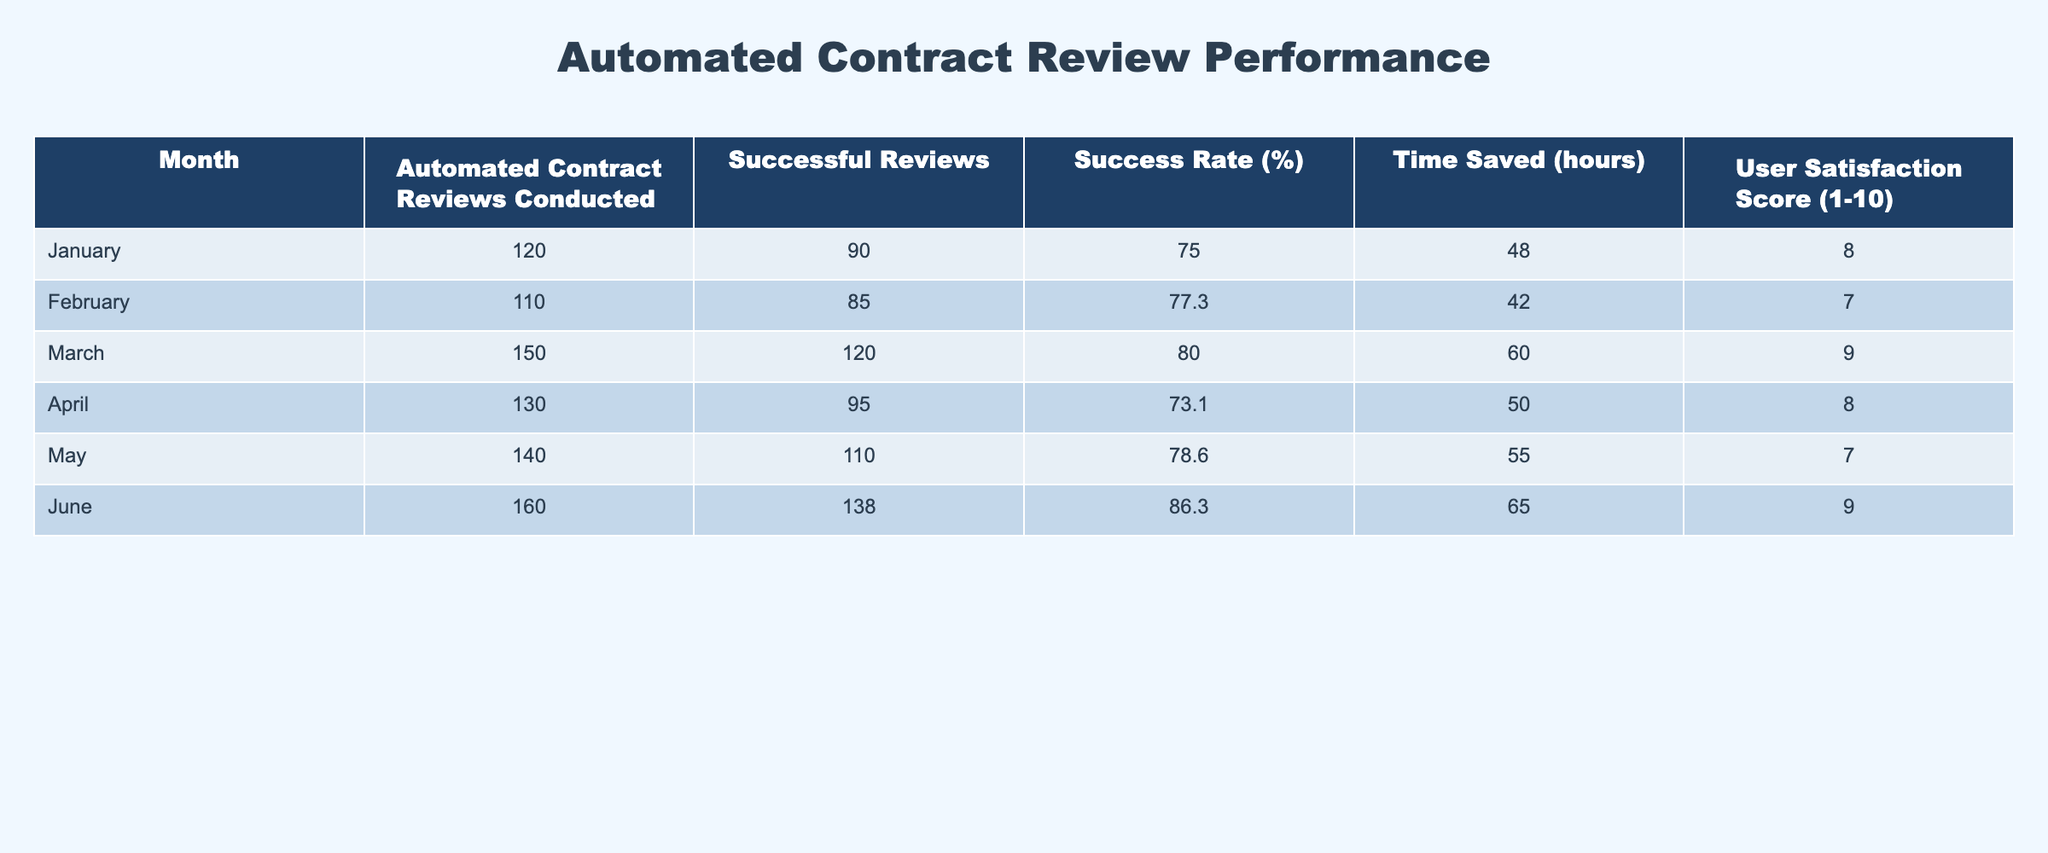What month had the highest success rate for automated contract reviews? Looking at the "Success Rate (%)" column, June shows the highest success rate of 86.3%. All other months have lower rates, with the next highest being March at 80.0%.
Answer: June What was the total number of successful reviews across all months? To find the total number of successful reviews, add the values from the "Successful Reviews" column: 90 + 85 + 120 + 95 + 110 + 138 = 738.
Answer: 738 What is the average user satisfaction score for the six months? To calculate the average user satisfaction score, sum the scores from the "User Satisfaction Score" column (8 + 7 + 9 + 8 + 7 + 9 = 58) and divide by the number of months (6): 58 / 6 = 9.67.
Answer: 9.67 Did the number of automated contract reviews conducted increase every month? To determine this, examine the "Automated Contract Reviews Conducted" column: January (120), February (110), March (150), April (130), May (140), June (160). The values show fluctuations, specifically a decrease from January to February, meaning the statement is false.
Answer: No Which month had the highest amount of time saved? By checking the "Time Saved (hours)" column, June reports the highest value of 65 hours saved, more than any other month. April, which follows, reported 50 hours saved.
Answer: June 